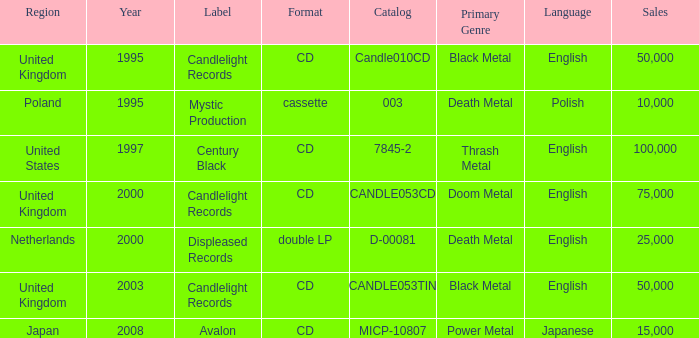What year did Japan form a label? 2008.0. Could you help me parse every detail presented in this table? {'header': ['Region', 'Year', 'Label', 'Format', 'Catalog', 'Primary Genre', 'Language', 'Sales'], 'rows': [['United Kingdom', '1995', 'Candlelight Records', 'CD', 'Candle010CD', 'Black Metal', 'English', '50,000'], ['Poland', '1995', 'Mystic Production', 'cassette', '003', 'Death Metal', 'Polish', '10,000'], ['United States', '1997', 'Century Black', 'CD', '7845-2', 'Thrash Metal', 'English', '100,000'], ['United Kingdom', '2000', 'Candlelight Records', 'CD', 'CANDLE053CD', 'Doom Metal', 'English', '75,000'], ['Netherlands', '2000', 'Displeased Records', 'double LP', 'D-00081', 'Death Metal', 'English', '25,000'], ['United Kingdom', '2003', 'Candlelight Records', 'CD', 'CANDLE053TIN', 'Black Metal', 'English', '50,000'], ['Japan', '2008', 'Avalon', 'CD', 'MICP-10807', 'Power Metal', 'Japanese', '15,000']]} 